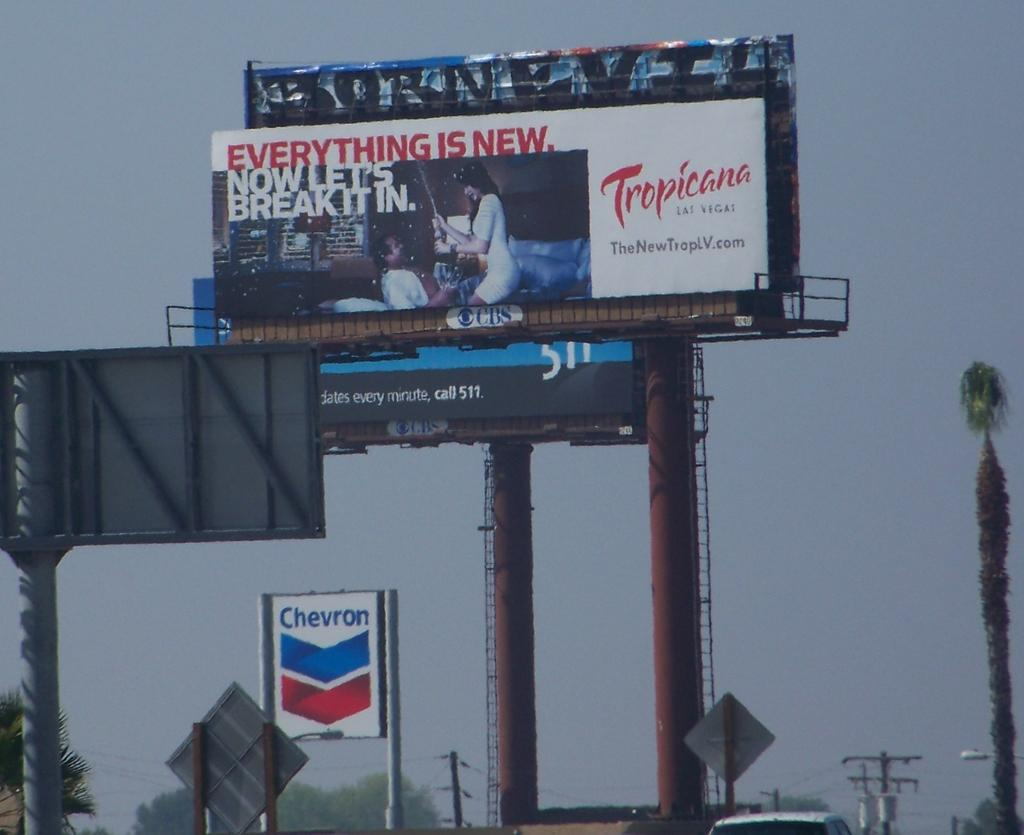<image>
Share a concise interpretation of the image provided. A billboard for Tropicana is above a Chevron sign. 